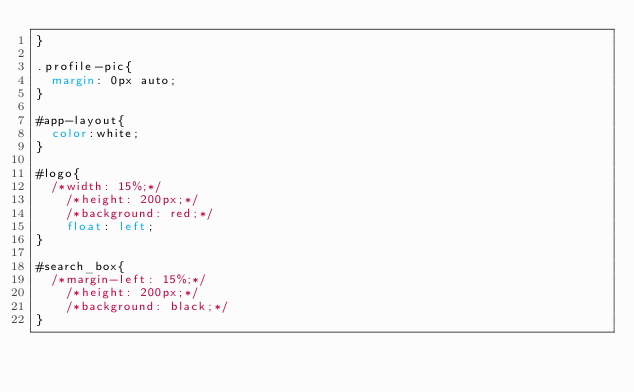<code> <loc_0><loc_0><loc_500><loc_500><_CSS_>}

.profile-pic{
	margin: 0px auto;
}

#app-layout{
	color:white;
}

#logo{
	/*width: 15%;*/
    /*height: 200px;*/
    /*background: red;*/
    float: left;
}

#search_box{
	/*margin-left: 15%;*/
    /*height: 200px;*/
    /*background: black;*/
}
</code> 